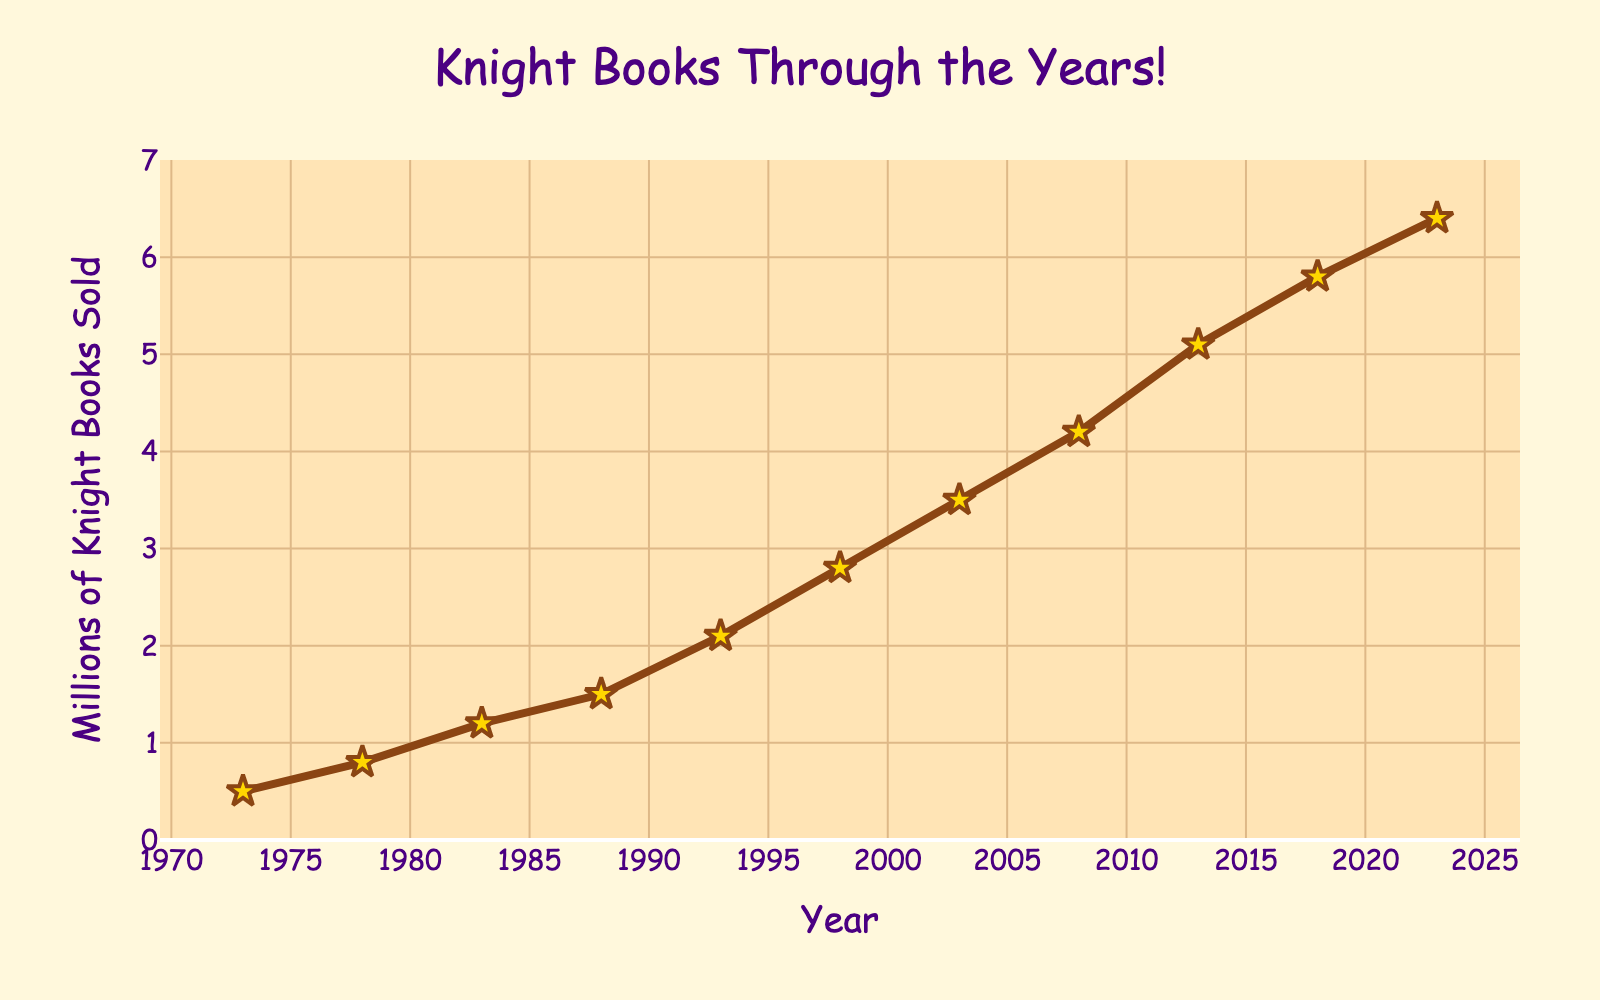What's the highest number of knight-themed books sold in a year? To find the highest number of books sold, look for the maximum value on the y-axis. The highest point on the plot corresponds to the year 2023 with 6.4 million books sold.
Answer: 6.4 million How many more knight-themed books were sold in 2023 compared to 1973? To find the difference, subtract the number of books sold in 1973 from the number sold in 2023. In 2023, 6.4 million books were sold, and in 1973, 0.5 million were sold. So, 6.4 - 0.5 = 5.9 million more books were sold in 2023 than in 1973.
Answer: 5.9 million Which year had a 50% increase in the number of knight-themed books sold compared to the previous year? A 50% increase can be calculated by taking the number of books in one year and checking if the number in the next year is 1.5 times greater. For example, from 0.8 million in 1978 to 1.2 million in 1983 (1.2 / 0.8 = 1.5) indicates a 50% increase from 1978 to 1983.
Answer: 1983 What is the average number of knight-themed books sold from 1973 to 2023? Add all the values and divide by the number of years. (0.5 + 0.8 + 1.2 + 1.5 + 2.1 + 2.8 + 3.5 + 4.2 + 5.1 + 5.8 + 6.4) / 11 = 33.9 / 11 = ~3.08 million
Answer: ~3.08 million In which decade did the number of knight-themed books sold double? Compare the values at the beginning and end of each decade. Between 1973 and 1983, books sold went from 0.5 million to 1.2 million, which does not double. However, from 1993 to 2003, books sold increased from 2.1 million to 3.5 million, which is not quite double, but close. The most direct doubling happens from bringing 1988's 1.5 to 1998's 2.8.
Answer: 1988 to 1998 Which year had the smallest number of knight-themed books sold? To identify the smallest number of books sold, look for the lowest point on the y-axis. The year 1973 had the smallest number with 0.5 million books sold.
Answer: 1973 Which year saw the highest percentage increase in knight-themed books sold compared to the previous year? Calculate the percentage increase for each interval by (new value - old value) / old value * 100%. From 1973 to 1978: (0.8 - 0.5)/0.5 = 0.6; from 1978 to 1983: (1.2 - 0.8)/0.8 = 0.5; etc. The highest percentage is from 1978 to 1983, with an increase of 50%.
Answer: 1983 What is the average number of knight-themed books sold in the decade starting from 1990? Calculate the average for years 1993, 1998, and 2003 (2.1 + 2.8 + 3.5) / 3 = 8.4 / 3 = 2.8 million
Answer: 2.8 million Between which consecutive years did the number of knight-themed books sold increase by the largest amount? Calculate the difference for each consecutive year: 0.3, 0.4, 0.3, 0.6, 0.7, 0.7, 0.7, 0.9, 0.7, 0.6 million. The largest difference is from 2008 to 2013 with 0.9 million increase.
Answer: 2008 to 2013 What is the total number of knight-themed books sold from 2003 to 2023? Add the values for the years 2003, 2008, 2013, 2018, and 2023: 3.5 + 4.2 + 5.1 + 5.8 + 6.4 = 25.0 million
Answer: 25.0 million 